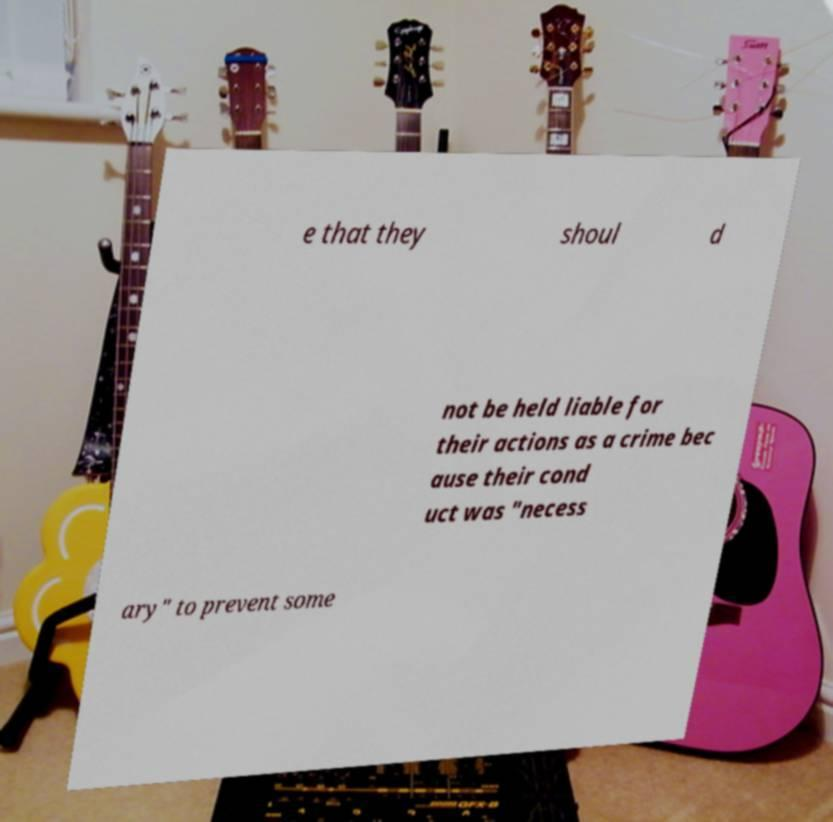Can you read and provide the text displayed in the image?This photo seems to have some interesting text. Can you extract and type it out for me? e that they shoul d not be held liable for their actions as a crime bec ause their cond uct was "necess ary" to prevent some 